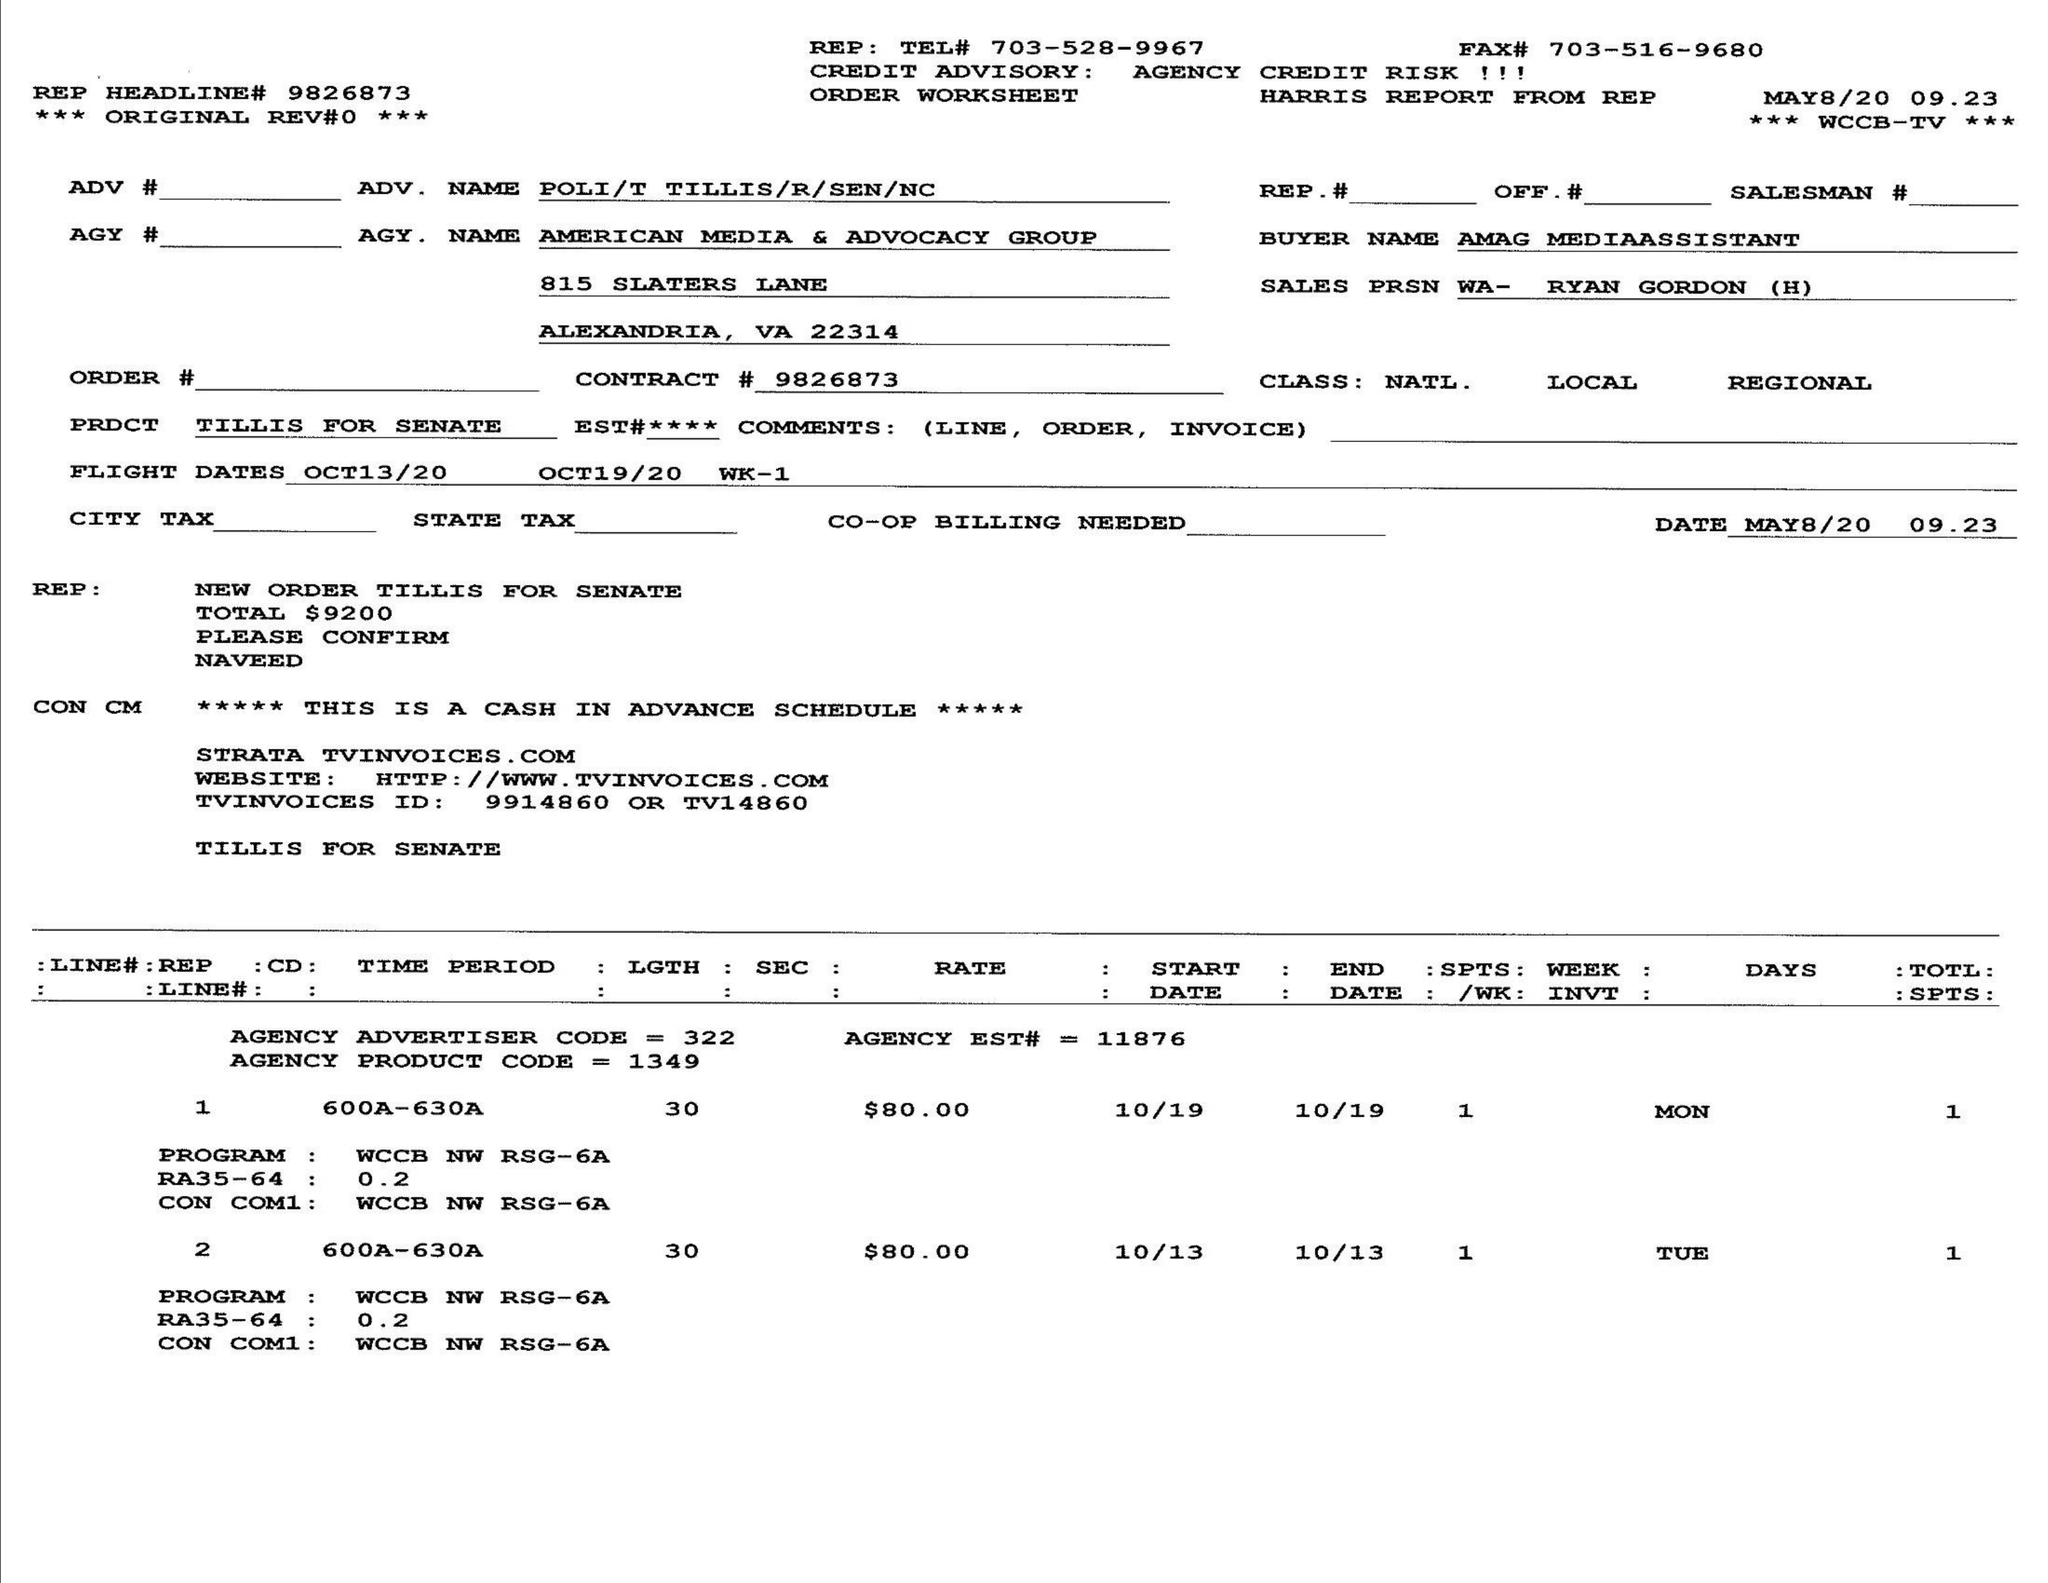What is the value for the advertiser?
Answer the question using a single word or phrase. POLI/TTILLIS/R/SEN/NC 